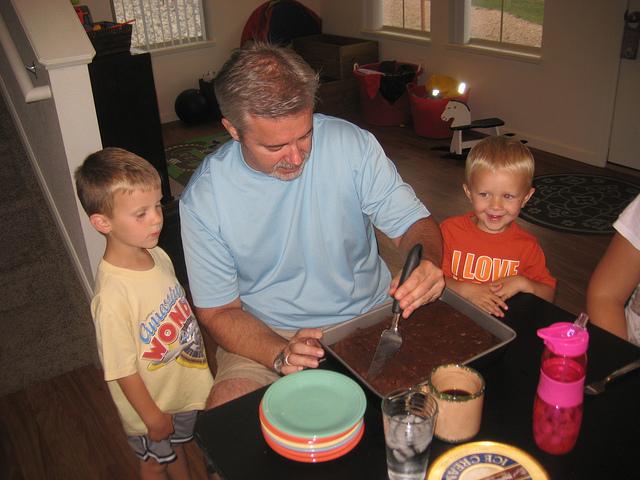Are all the plates the same color?
Short answer required. No. What are these people making?
Give a very brief answer. Brownies. What is the man doing with the cake knife?
Concise answer only. Cutting cake. How many people are there?
Short answer required. 4. What are the children doing in the picture?
Quick response, please. Waiting. What is sitting in front of the man on the right?
Concise answer only. Cake. 